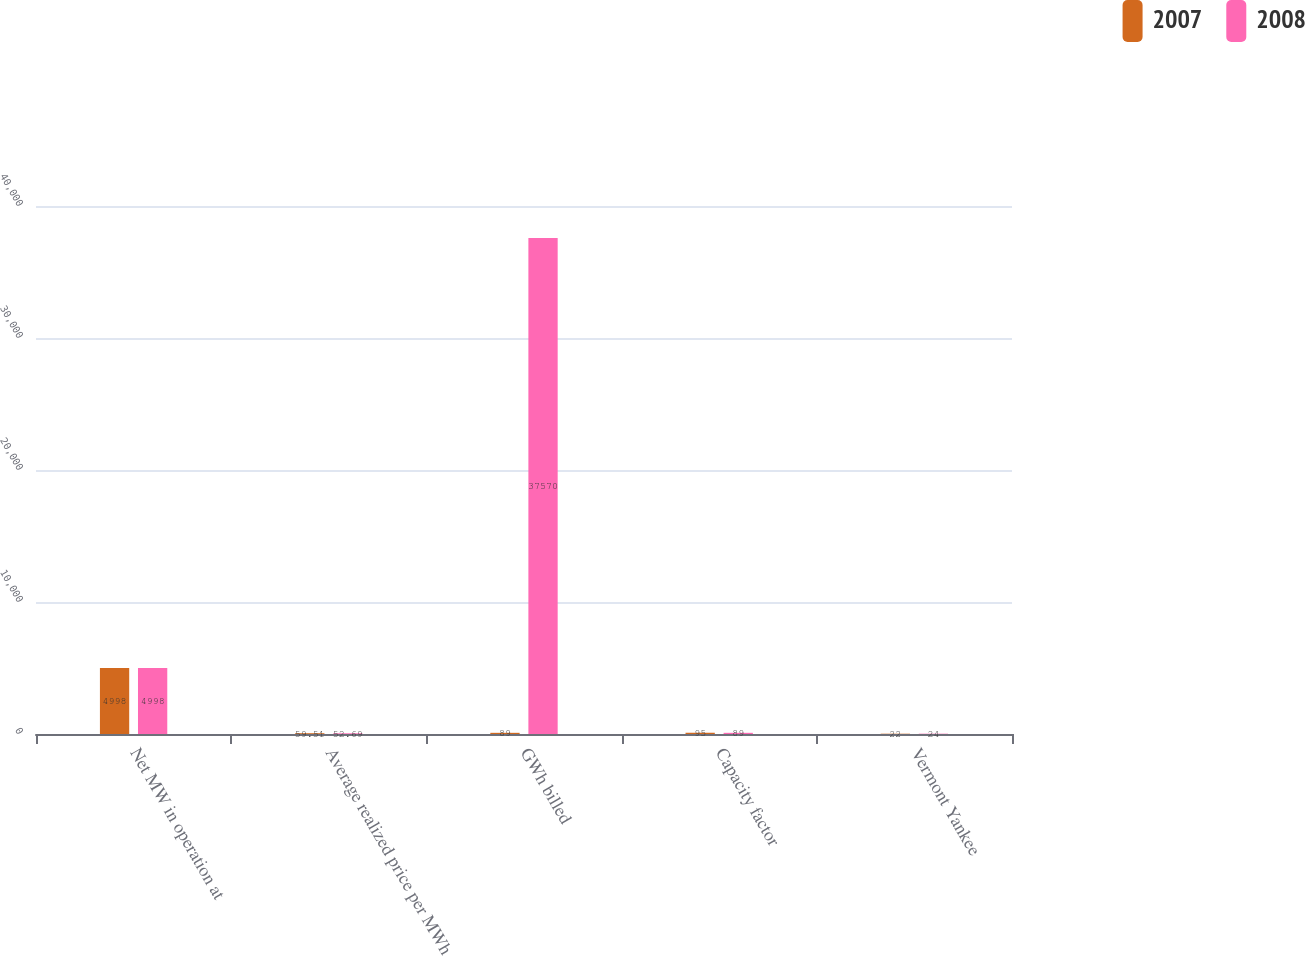Convert chart to OTSL. <chart><loc_0><loc_0><loc_500><loc_500><stacked_bar_chart><ecel><fcel>Net MW in operation at<fcel>Average realized price per MWh<fcel>GWh billed<fcel>Capacity factor<fcel>Vermont Yankee<nl><fcel>2007<fcel>4998<fcel>59.51<fcel>89<fcel>95<fcel>22<nl><fcel>2008<fcel>4998<fcel>52.69<fcel>37570<fcel>89<fcel>24<nl></chart> 